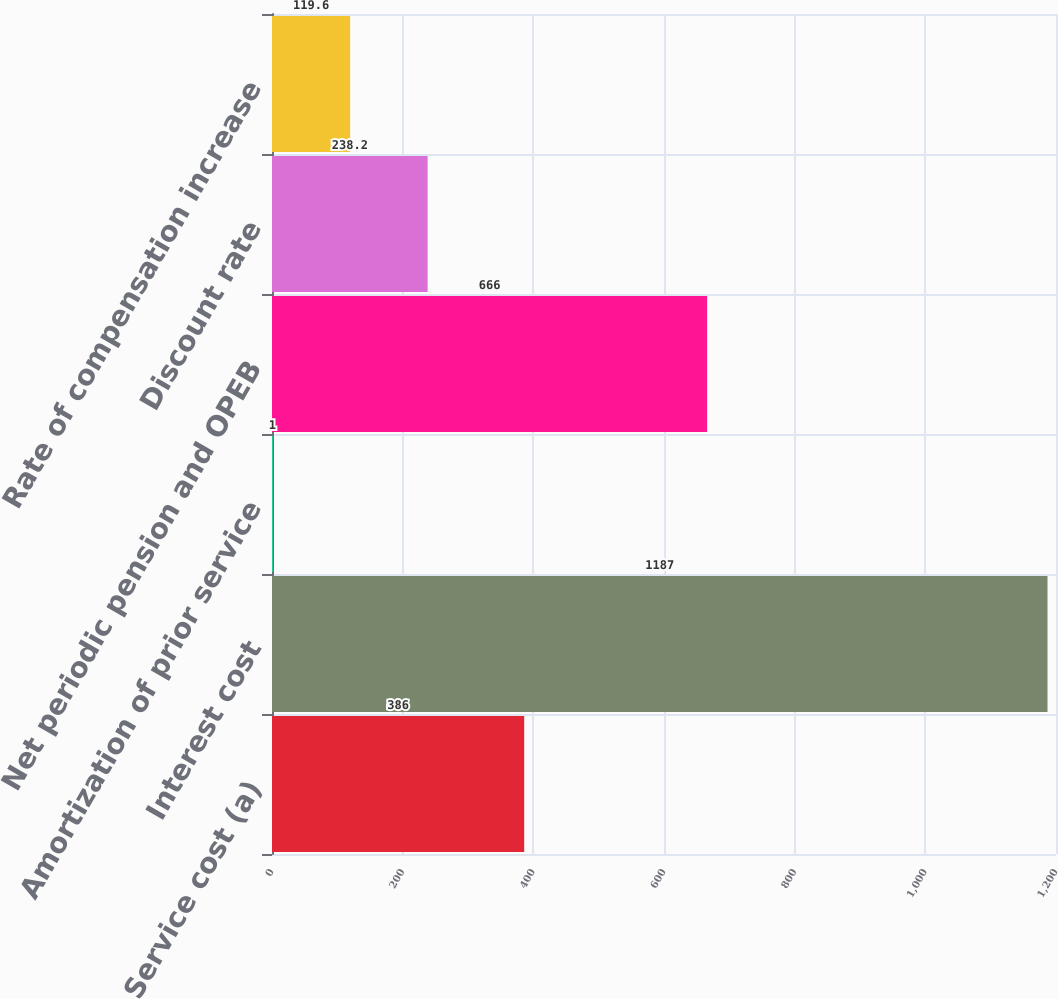<chart> <loc_0><loc_0><loc_500><loc_500><bar_chart><fcel>Service cost (a)<fcel>Interest cost<fcel>Amortization of prior service<fcel>Net periodic pension and OPEB<fcel>Discount rate<fcel>Rate of compensation increase<nl><fcel>386<fcel>1187<fcel>1<fcel>666<fcel>238.2<fcel>119.6<nl></chart> 